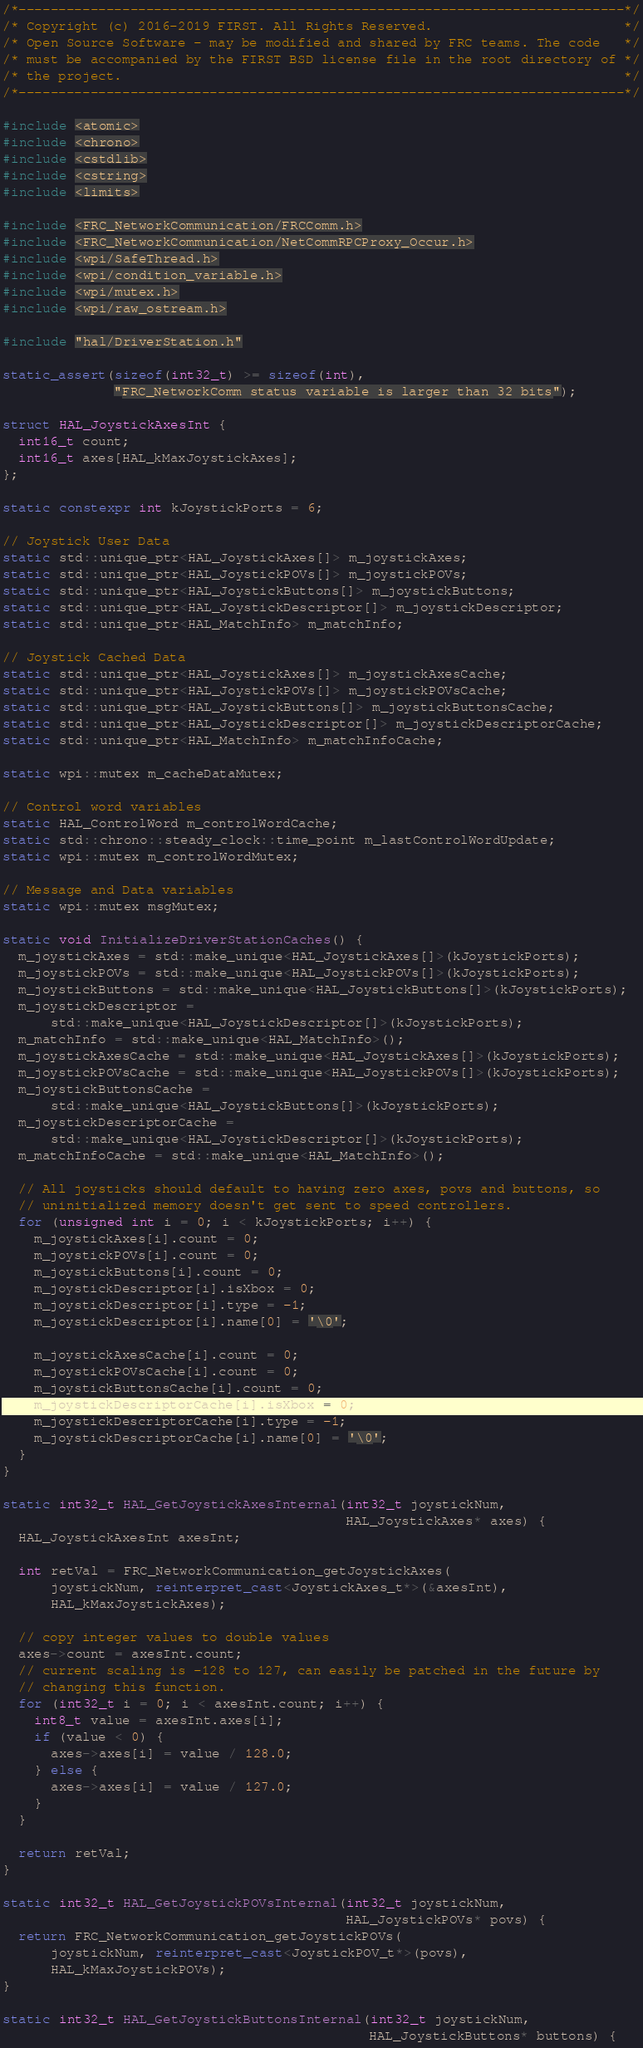Convert code to text. <code><loc_0><loc_0><loc_500><loc_500><_C++_>/*----------------------------------------------------------------------------*/
/* Copyright (c) 2016-2019 FIRST. All Rights Reserved.                        */
/* Open Source Software - may be modified and shared by FRC teams. The code   */
/* must be accompanied by the FIRST BSD license file in the root directory of */
/* the project.                                                               */
/*----------------------------------------------------------------------------*/

#include <atomic>
#include <chrono>
#include <cstdlib>
#include <cstring>
#include <limits>

#include <FRC_NetworkCommunication/FRCComm.h>
#include <FRC_NetworkCommunication/NetCommRPCProxy_Occur.h>
#include <wpi/SafeThread.h>
#include <wpi/condition_variable.h>
#include <wpi/mutex.h>
#include <wpi/raw_ostream.h>

#include "hal/DriverStation.h"

static_assert(sizeof(int32_t) >= sizeof(int),
              "FRC_NetworkComm status variable is larger than 32 bits");

struct HAL_JoystickAxesInt {
  int16_t count;
  int16_t axes[HAL_kMaxJoystickAxes];
};

static constexpr int kJoystickPorts = 6;

// Joystick User Data
static std::unique_ptr<HAL_JoystickAxes[]> m_joystickAxes;
static std::unique_ptr<HAL_JoystickPOVs[]> m_joystickPOVs;
static std::unique_ptr<HAL_JoystickButtons[]> m_joystickButtons;
static std::unique_ptr<HAL_JoystickDescriptor[]> m_joystickDescriptor;
static std::unique_ptr<HAL_MatchInfo> m_matchInfo;

// Joystick Cached Data
static std::unique_ptr<HAL_JoystickAxes[]> m_joystickAxesCache;
static std::unique_ptr<HAL_JoystickPOVs[]> m_joystickPOVsCache;
static std::unique_ptr<HAL_JoystickButtons[]> m_joystickButtonsCache;
static std::unique_ptr<HAL_JoystickDescriptor[]> m_joystickDescriptorCache;
static std::unique_ptr<HAL_MatchInfo> m_matchInfoCache;

static wpi::mutex m_cacheDataMutex;

// Control word variables
static HAL_ControlWord m_controlWordCache;
static std::chrono::steady_clock::time_point m_lastControlWordUpdate;
static wpi::mutex m_controlWordMutex;

// Message and Data variables
static wpi::mutex msgMutex;

static void InitializeDriverStationCaches() {
  m_joystickAxes = std::make_unique<HAL_JoystickAxes[]>(kJoystickPorts);
  m_joystickPOVs = std::make_unique<HAL_JoystickPOVs[]>(kJoystickPorts);
  m_joystickButtons = std::make_unique<HAL_JoystickButtons[]>(kJoystickPorts);
  m_joystickDescriptor =
      std::make_unique<HAL_JoystickDescriptor[]>(kJoystickPorts);
  m_matchInfo = std::make_unique<HAL_MatchInfo>();
  m_joystickAxesCache = std::make_unique<HAL_JoystickAxes[]>(kJoystickPorts);
  m_joystickPOVsCache = std::make_unique<HAL_JoystickPOVs[]>(kJoystickPorts);
  m_joystickButtonsCache =
      std::make_unique<HAL_JoystickButtons[]>(kJoystickPorts);
  m_joystickDescriptorCache =
      std::make_unique<HAL_JoystickDescriptor[]>(kJoystickPorts);
  m_matchInfoCache = std::make_unique<HAL_MatchInfo>();

  // All joysticks should default to having zero axes, povs and buttons, so
  // uninitialized memory doesn't get sent to speed controllers.
  for (unsigned int i = 0; i < kJoystickPorts; i++) {
    m_joystickAxes[i].count = 0;
    m_joystickPOVs[i].count = 0;
    m_joystickButtons[i].count = 0;
    m_joystickDescriptor[i].isXbox = 0;
    m_joystickDescriptor[i].type = -1;
    m_joystickDescriptor[i].name[0] = '\0';

    m_joystickAxesCache[i].count = 0;
    m_joystickPOVsCache[i].count = 0;
    m_joystickButtonsCache[i].count = 0;
    m_joystickDescriptorCache[i].isXbox = 0;
    m_joystickDescriptorCache[i].type = -1;
    m_joystickDescriptorCache[i].name[0] = '\0';
  }
}

static int32_t HAL_GetJoystickAxesInternal(int32_t joystickNum,
                                           HAL_JoystickAxes* axes) {
  HAL_JoystickAxesInt axesInt;

  int retVal = FRC_NetworkCommunication_getJoystickAxes(
      joystickNum, reinterpret_cast<JoystickAxes_t*>(&axesInt),
      HAL_kMaxJoystickAxes);

  // copy integer values to double values
  axes->count = axesInt.count;
  // current scaling is -128 to 127, can easily be patched in the future by
  // changing this function.
  for (int32_t i = 0; i < axesInt.count; i++) {
    int8_t value = axesInt.axes[i];
    if (value < 0) {
      axes->axes[i] = value / 128.0;
    } else {
      axes->axes[i] = value / 127.0;
    }
  }

  return retVal;
}

static int32_t HAL_GetJoystickPOVsInternal(int32_t joystickNum,
                                           HAL_JoystickPOVs* povs) {
  return FRC_NetworkCommunication_getJoystickPOVs(
      joystickNum, reinterpret_cast<JoystickPOV_t*>(povs),
      HAL_kMaxJoystickPOVs);
}

static int32_t HAL_GetJoystickButtonsInternal(int32_t joystickNum,
                                              HAL_JoystickButtons* buttons) {</code> 